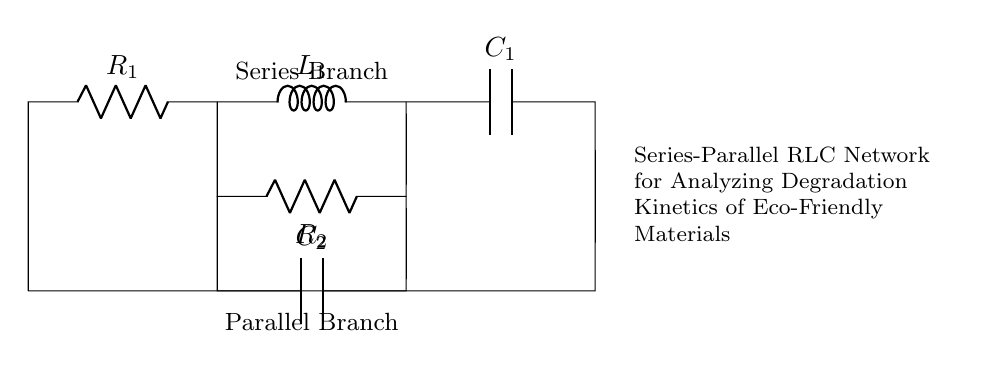What is the resistance in series? There are two resistors in series, R1 and R2. Therefore, the total resistance in series is the sum of these resistances: R_total = R1 + R2.
Answer: R1 + R2 What is the total capacitance in parallel? The circuit has capacitor C2 in parallel with C1. In parallel, the total capacitance is given by: C_total = C1 + C2.
Answer: C1 + C2 What type of circuit configuration is shown? The circuit consists of a combination of series and parallel arrangements of resistors, an inductor, and capacitors. This is referred to as a series-parallel RLC network.
Answer: Series-parallel RLC network What is the function of the inductance in this circuit? The inductor L1's role in the circuit is to oppose changes in current, which can help regulate the flow of voltage and improve stability during the degradation process being studied.
Answer: Oppose current changes What are the components connected in series? The components in series are R1, L1, and C1, as they are arranged sequentially along the same path without any branching.
Answer: R1, L1, C1 How do these components affect the degradation kinetics? The series-parallel RLC configuration can mimic real-world behavior of biodegradable materials, allowing for the analysis of how these materials degrade over time under varying electrical conditions.
Answer: Mimics degradation behavior 